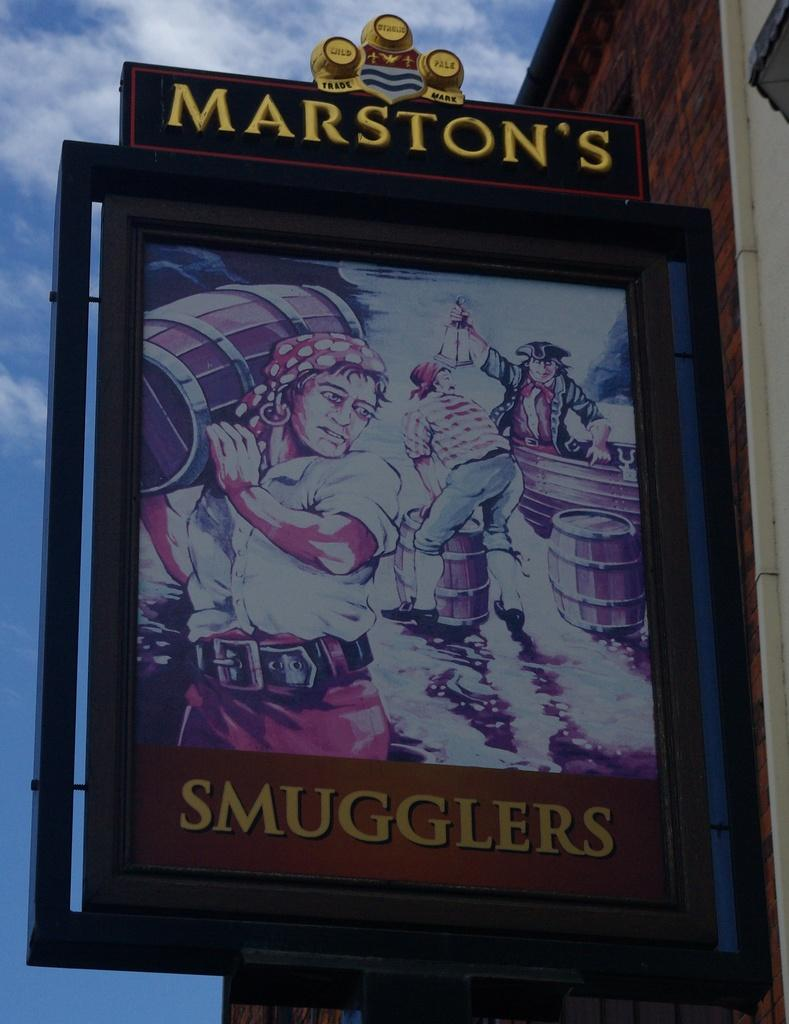<image>
Summarize the visual content of the image. a picture showing a pirate under the label marston's smugglers 